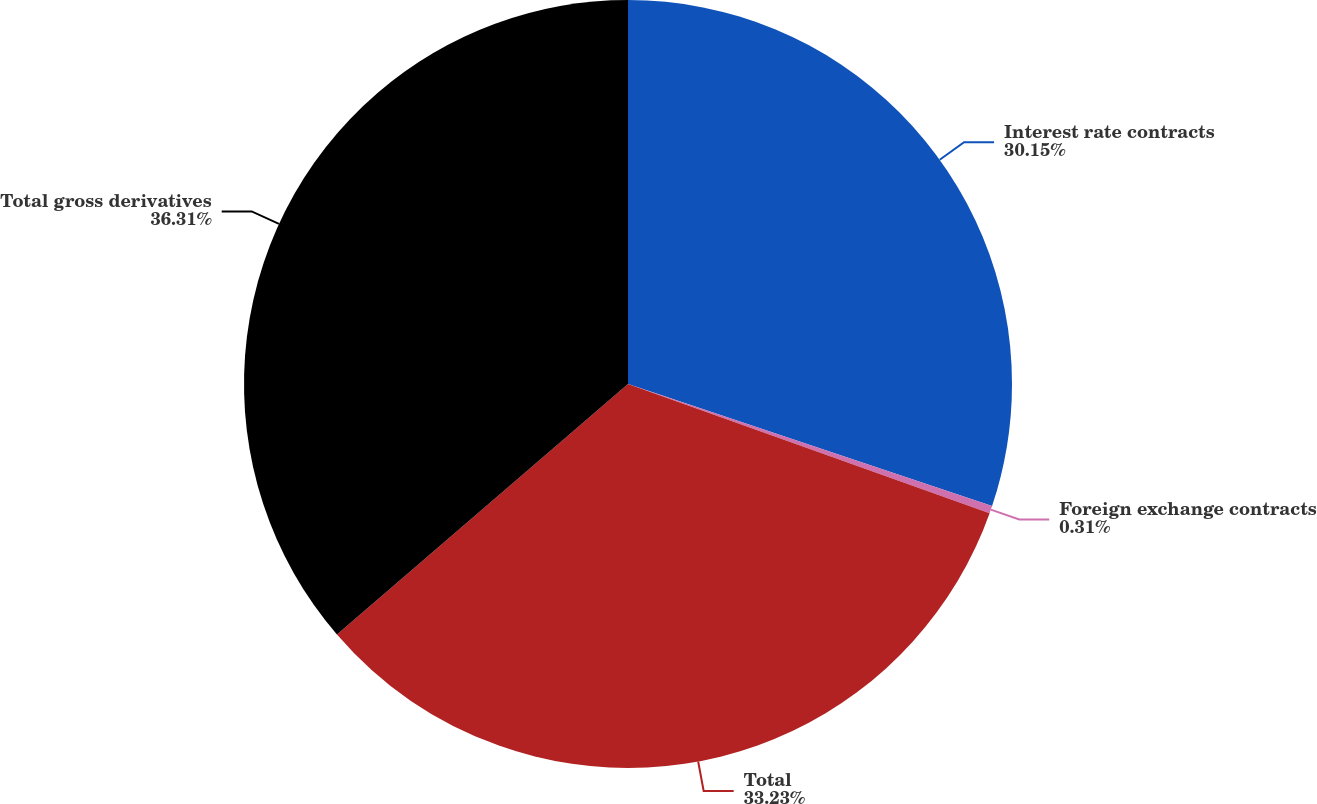<chart> <loc_0><loc_0><loc_500><loc_500><pie_chart><fcel>Interest rate contracts<fcel>Foreign exchange contracts<fcel>Total<fcel>Total gross derivatives<nl><fcel>30.15%<fcel>0.31%<fcel>33.23%<fcel>36.31%<nl></chart> 